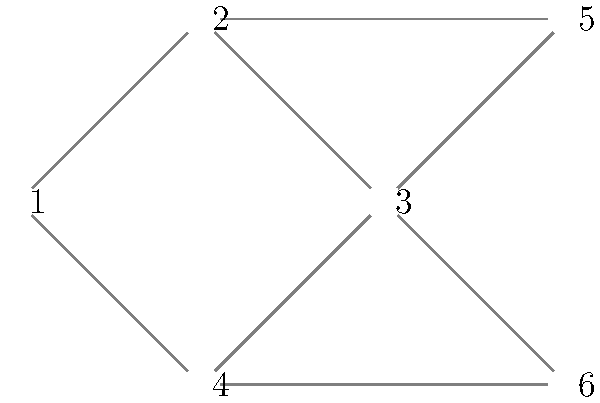In our recent collaboration on network optimization, Dr. Mookerjee proposed a graph representation for a communication network. Given the network topology shown above, what is the minimum number of edges that need to be removed to disconnect node 1 from node 6, assuming all edges have equal weight? To solve this problem, we need to find the minimum cut between nodes 1 and 6. Let's approach this step-by-step:

1. Identify all possible paths from node 1 to node 6:
   Path 1: 1 - 2 - 5 - 3 - 6
   Path 2: 1 - 2 - 3 - 6
   Path 3: 1 - 4 - 3 - 6

2. Observe that all paths must go through node 3 to reach node 6.

3. To disconnect node 1 from node 6, we need to cut all paths that connect node 1 to node 3, or cut the single edge connecting node 3 to node 6.

4. Cutting paths from node 1 to node 3:
   - We would need to cut at least 2 edges: (1-2 and 1-4) or (2-3 and 4-3)

5. Cutting the single edge from node 3 to node 6:
   - We only need to cut 1 edge: 3-6

6. The minimum number of edges to cut is the smaller of these two options.

Therefore, the minimum number of edges to remove is 1, which is the edge connecting node 3 to node 6.
Answer: 1 